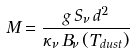<formula> <loc_0><loc_0><loc_500><loc_500>M = \frac { g \, S _ { \nu } \, d ^ { 2 } } { \kappa _ { \nu } \, B _ { \nu } \, ( T _ { d u s t } ) }</formula> 